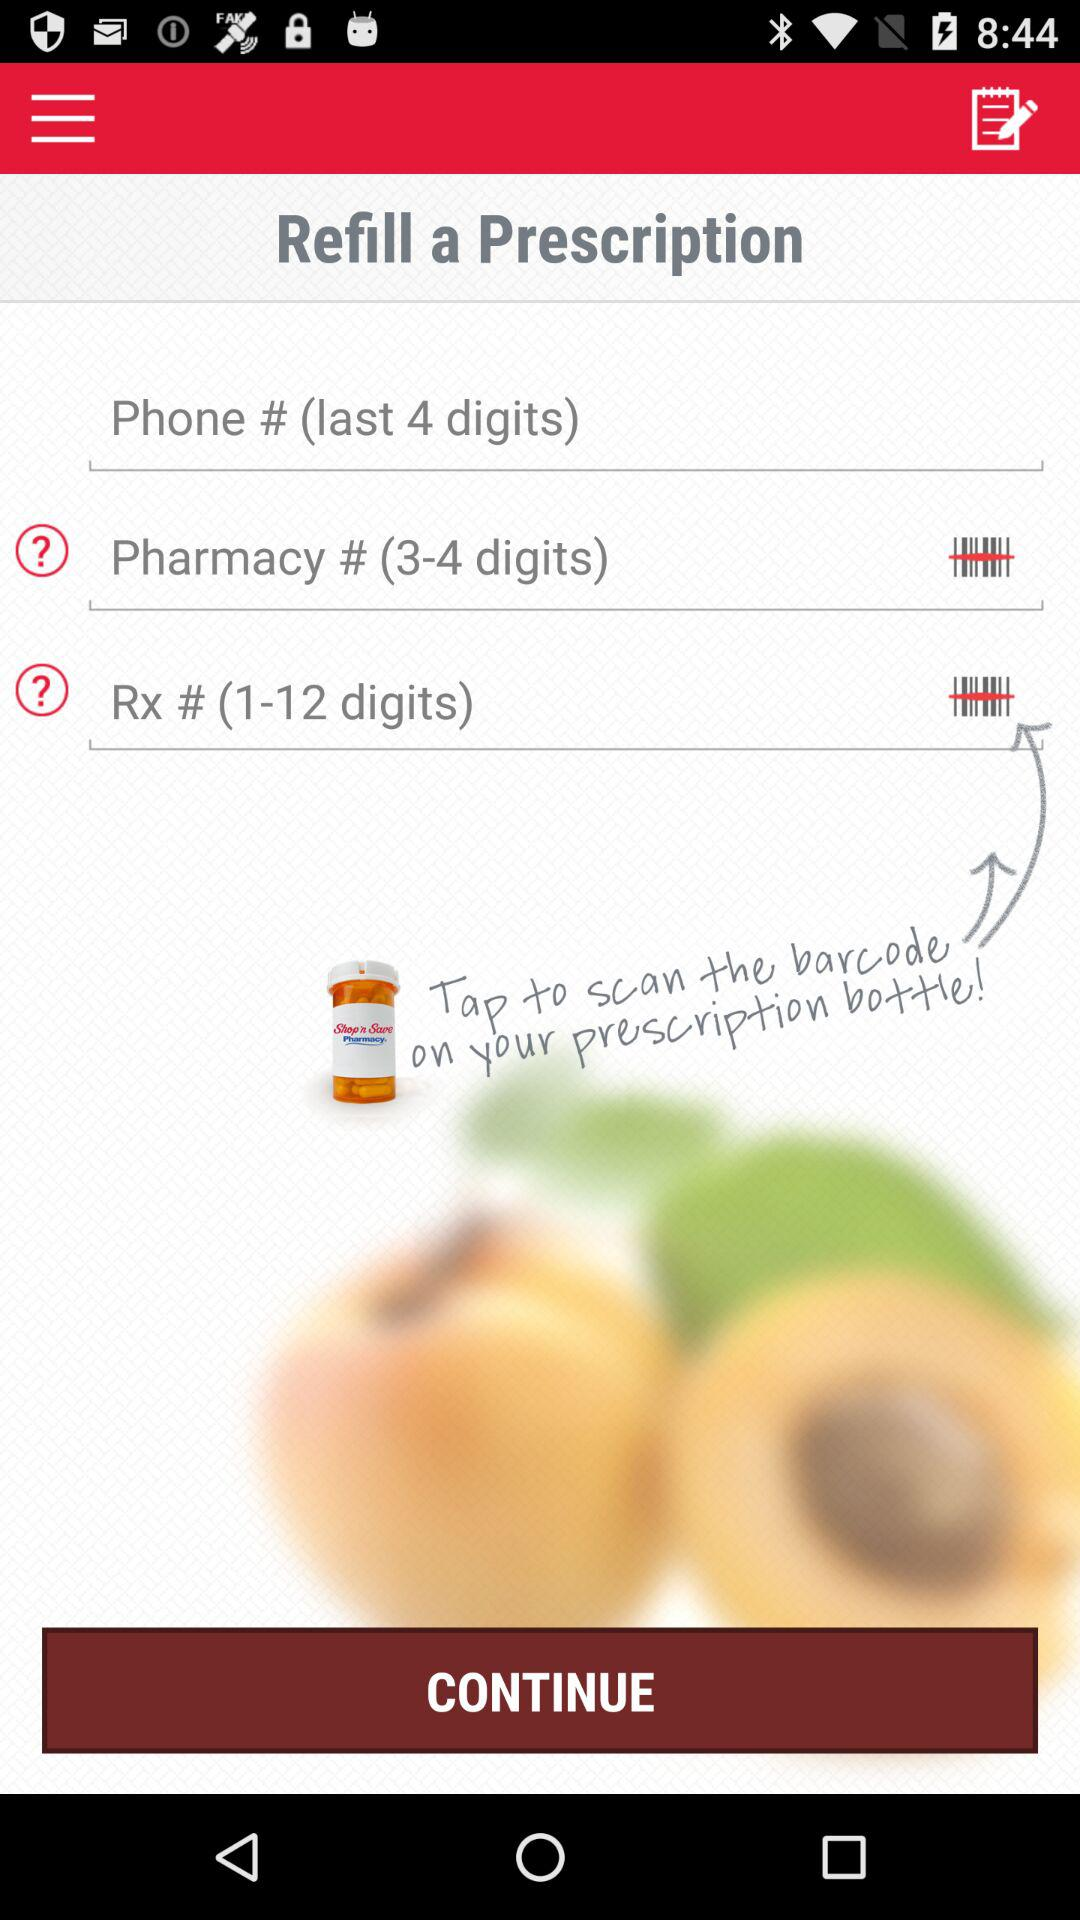How many digits long is the longest text input?
Answer the question using a single word or phrase. 12 